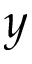Convert formula to latex. <formula><loc_0><loc_0><loc_500><loc_500>y</formula> 